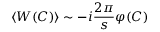<formula> <loc_0><loc_0><loc_500><loc_500>\langle W ( C ) \rangle \sim - i \frac { 2 \pi } { s } \varphi ( C )</formula> 